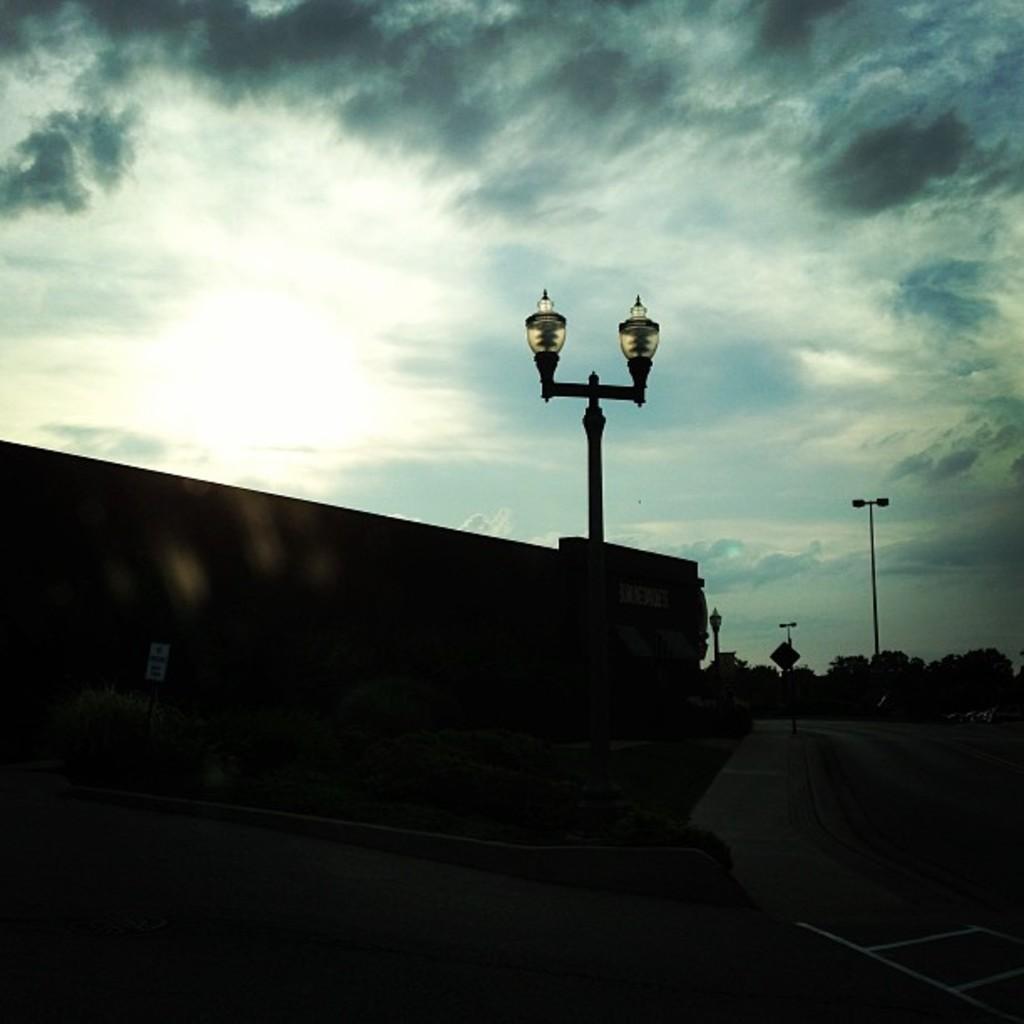How would you summarize this image in a sentence or two? In this image I can see a wall, road and two poles. In the background there are some trees. On the top of the image I can see the sky. 